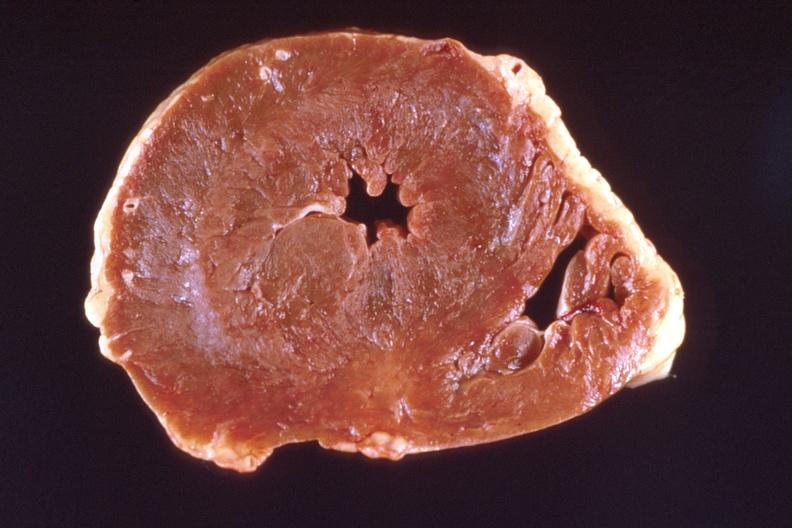does this image show heart?
Answer the question using a single word or phrase. Yes 